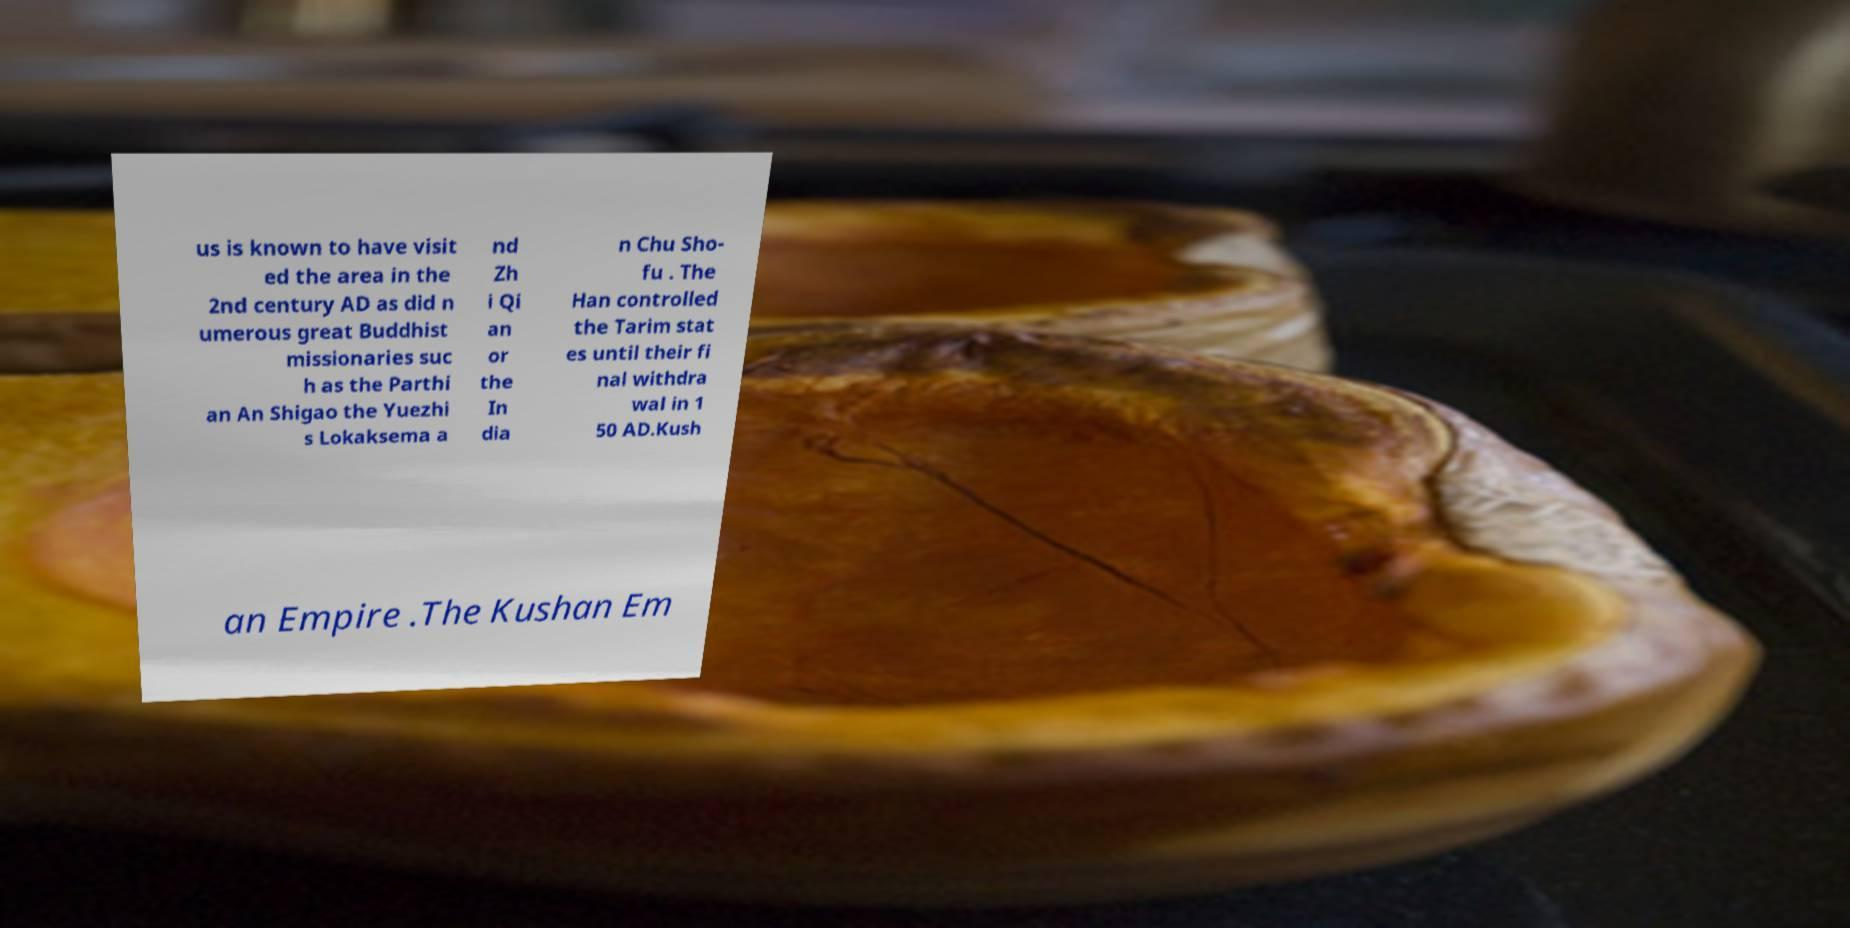Can you read and provide the text displayed in the image?This photo seems to have some interesting text. Can you extract and type it out for me? us is known to have visit ed the area in the 2nd century AD as did n umerous great Buddhist missionaries suc h as the Parthi an An Shigao the Yuezhi s Lokaksema a nd Zh i Qi an or the In dia n Chu Sho- fu . The Han controlled the Tarim stat es until their fi nal withdra wal in 1 50 AD.Kush an Empire .The Kushan Em 